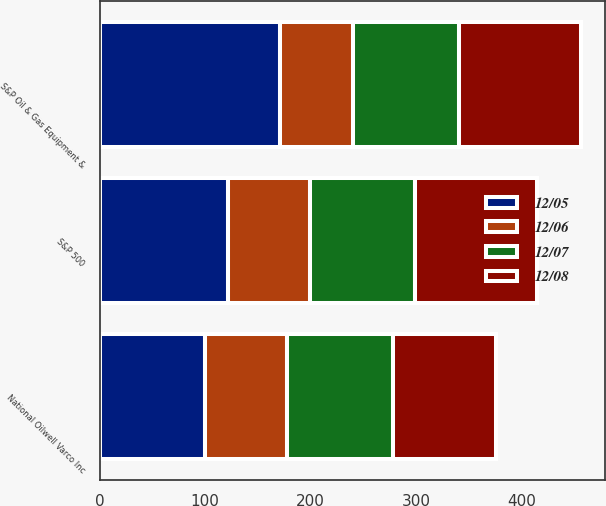Convert chart. <chart><loc_0><loc_0><loc_500><loc_500><stacked_bar_chart><ecel><fcel>National Oilwell Varco Inc<fcel>S&P 500<fcel>S&P Oil & Gas Equipment &<nl><fcel>12/07<fcel>100<fcel>100<fcel>100<nl><fcel>12/08<fcel>97.58<fcel>115.8<fcel>115.54<nl><fcel>12/05<fcel>100<fcel>122.16<fcel>170.88<nl><fcel>12/06<fcel>77.96<fcel>76.96<fcel>69.76<nl></chart> 